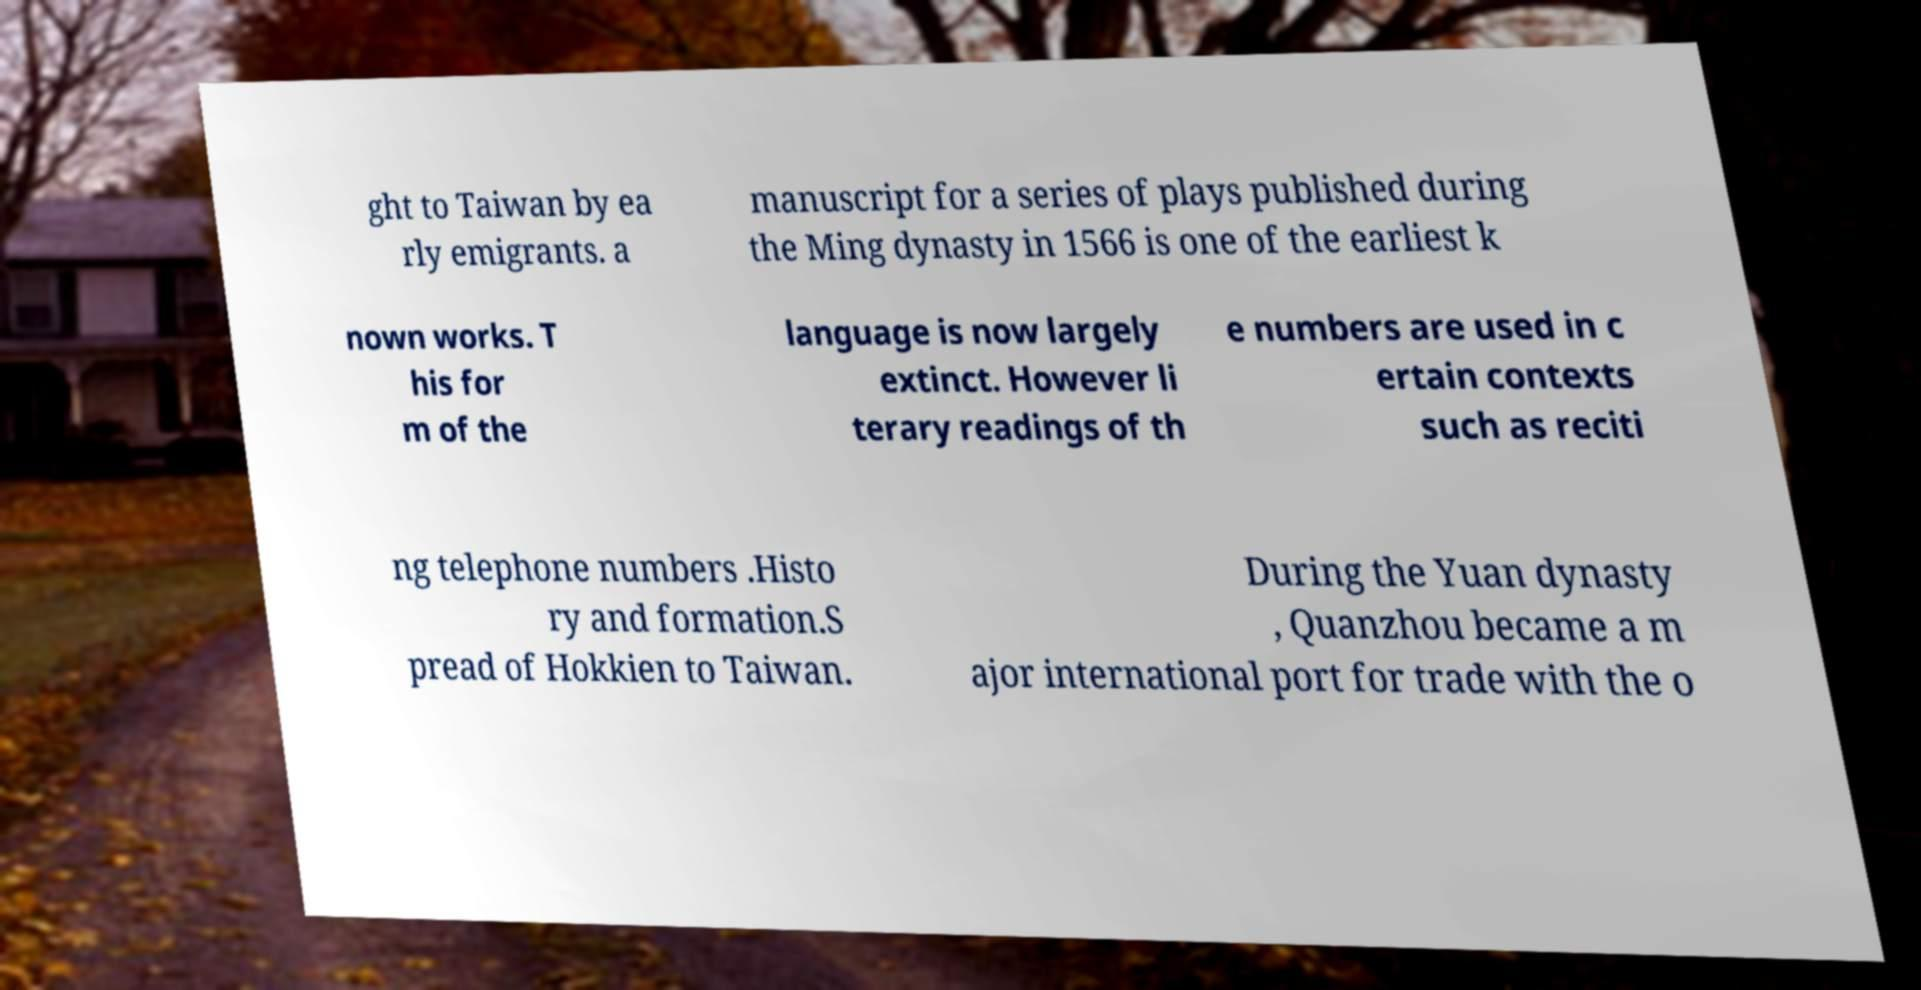There's text embedded in this image that I need extracted. Can you transcribe it verbatim? ght to Taiwan by ea rly emigrants. a manuscript for a series of plays published during the Ming dynasty in 1566 is one of the earliest k nown works. T his for m of the language is now largely extinct. However li terary readings of th e numbers are used in c ertain contexts such as reciti ng telephone numbers .Histo ry and formation.S pread of Hokkien to Taiwan. During the Yuan dynasty , Quanzhou became a m ajor international port for trade with the o 